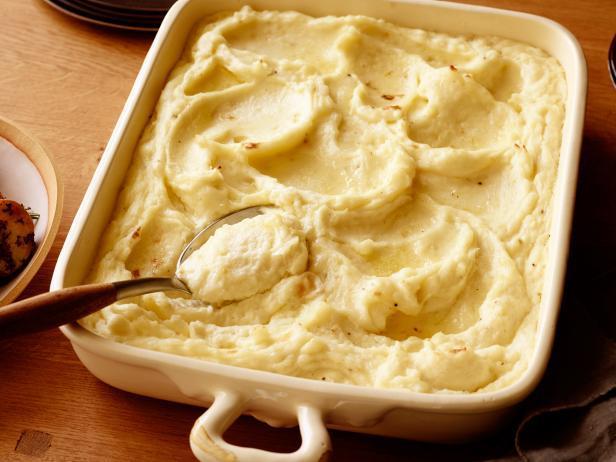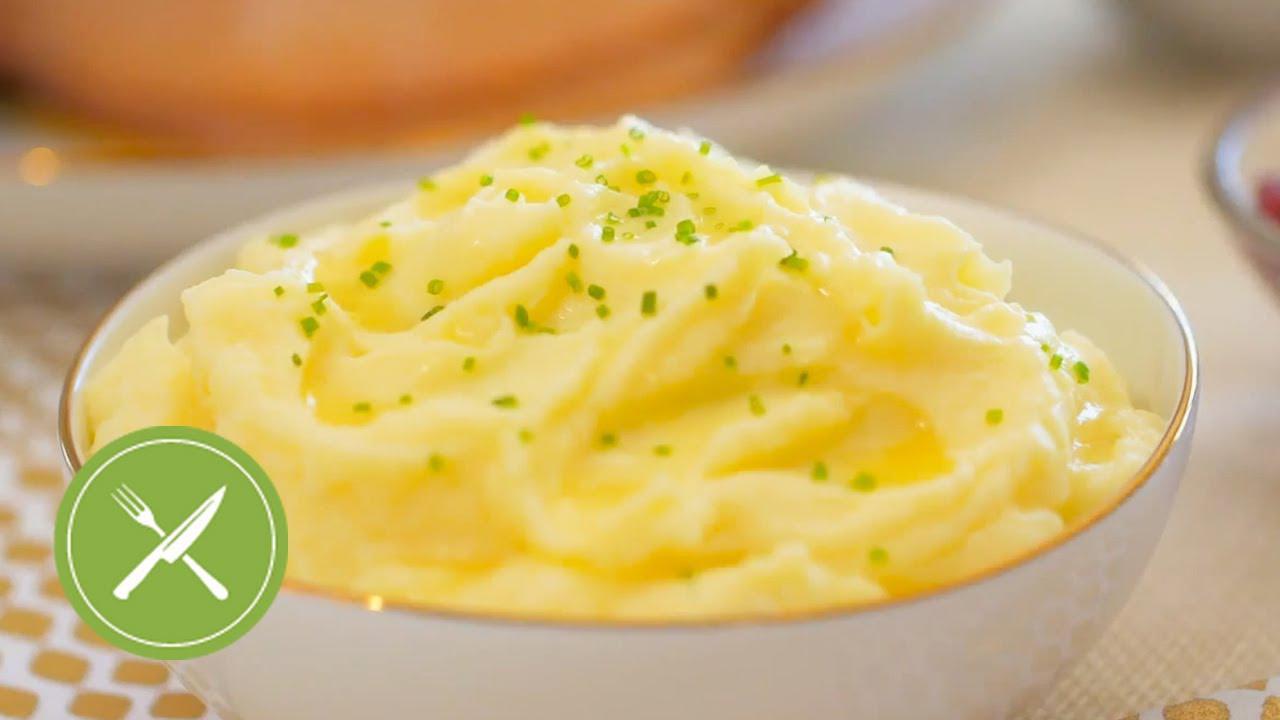The first image is the image on the left, the second image is the image on the right. Given the left and right images, does the statement "There is a utensil in the food in the image on the left." hold true? Answer yes or no. Yes. 